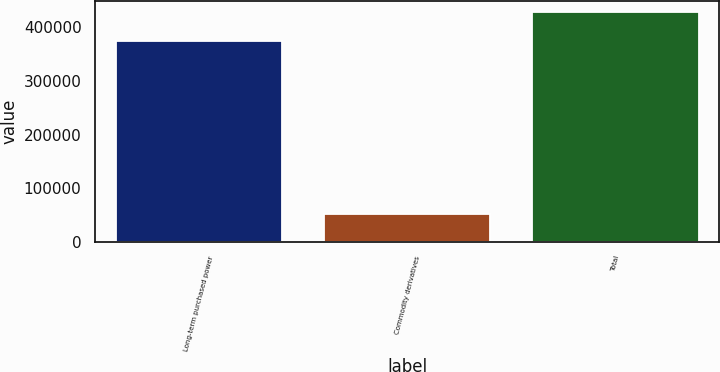<chart> <loc_0><loc_0><loc_500><loc_500><bar_chart><fcel>Long-term purchased power<fcel>Commodity derivatives<fcel>Total<nl><fcel>374692<fcel>52968<fcel>427660<nl></chart> 